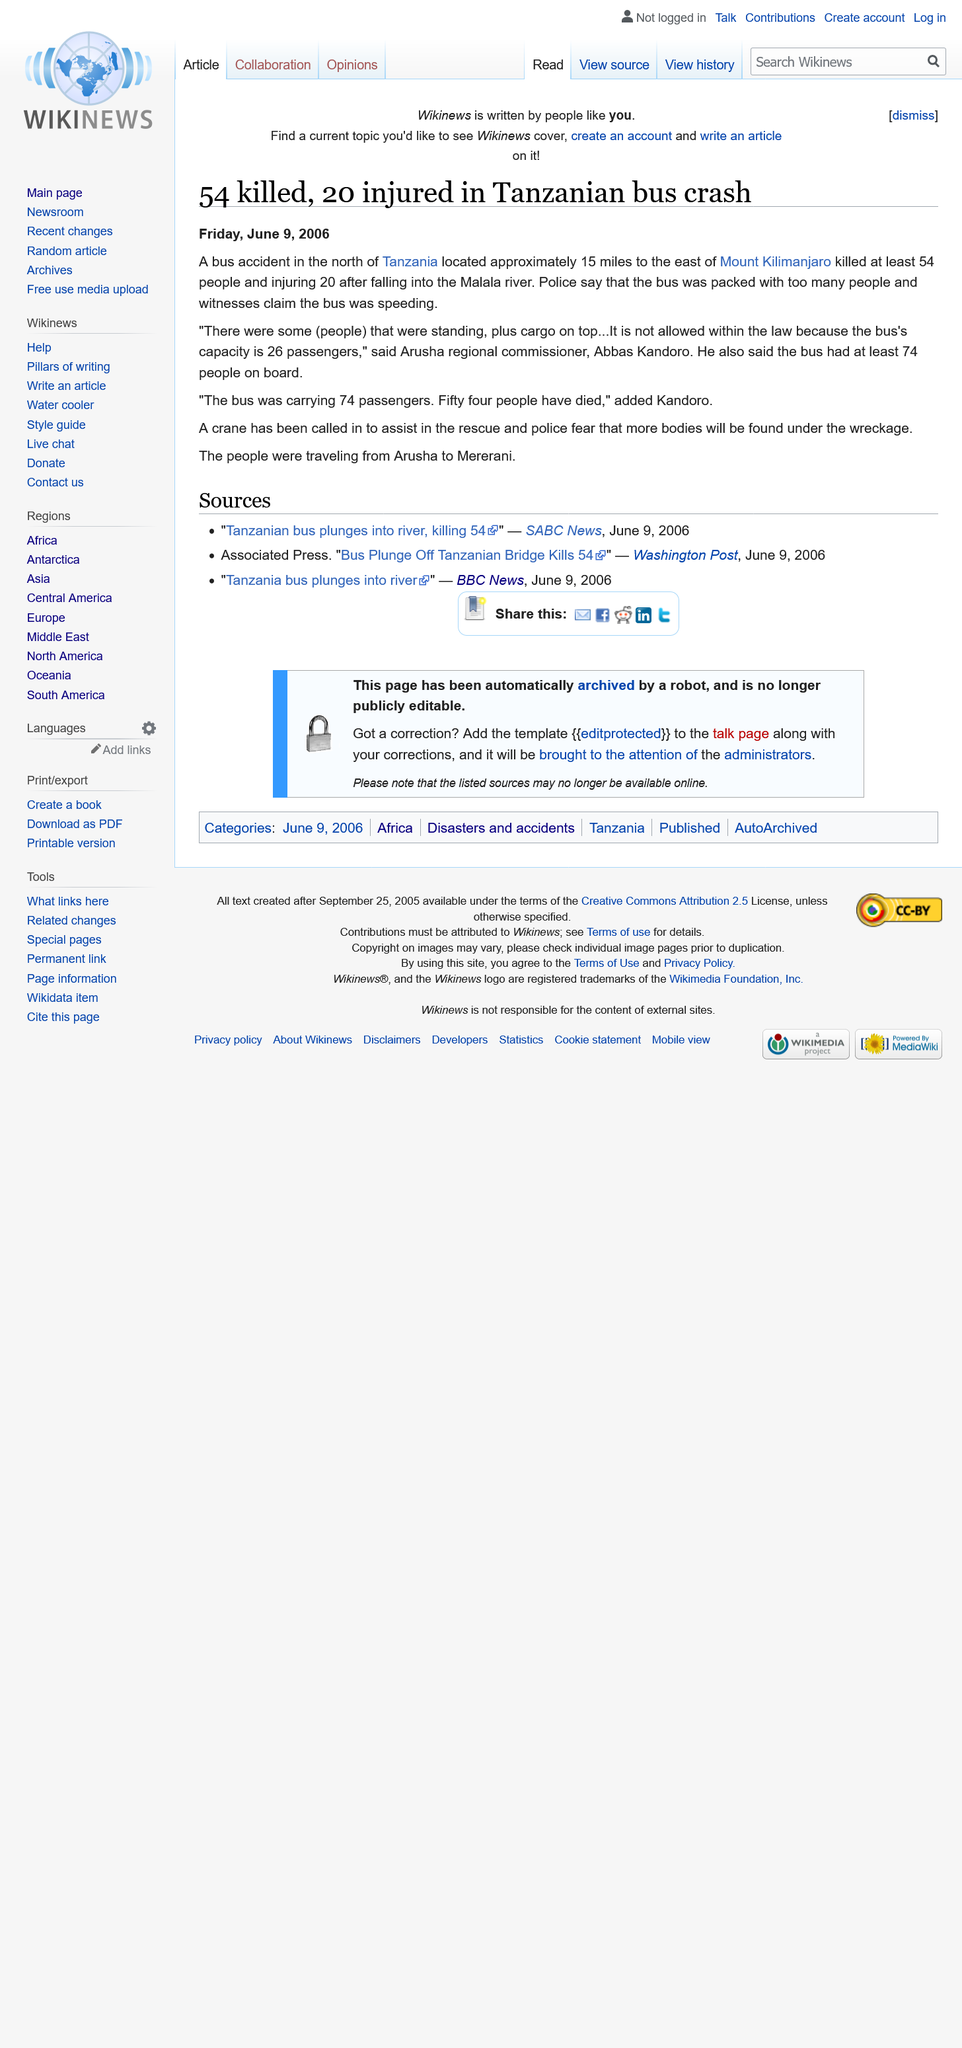Mention a couple of crucial points in this snapshot. The passengers were traveling from Arusha, a location in Tanzania. There were 74 passengers in total, and of those, 20 were injured. The bus had 74 passengers on board and a capacity for 26 passengers, exceeding its own capacity. 